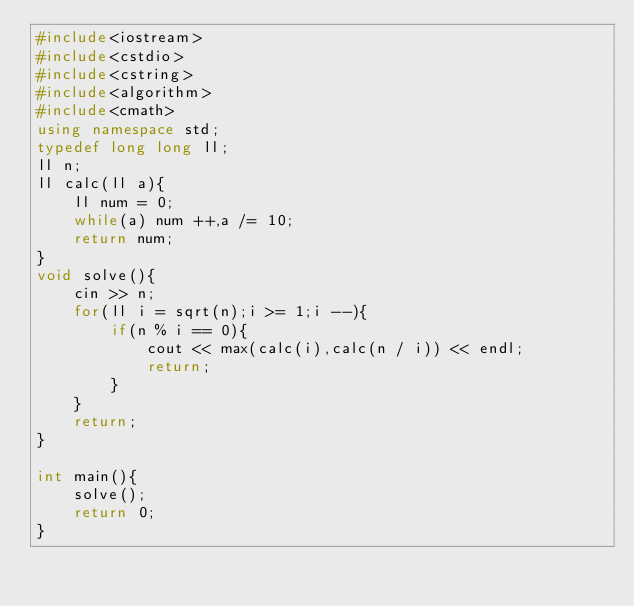<code> <loc_0><loc_0><loc_500><loc_500><_C++_>#include<iostream>
#include<cstdio>
#include<cstring>
#include<algorithm>
#include<cmath> 
using namespace std;
typedef long long ll;
ll n;
ll calc(ll a){
	ll num = 0;
	while(a) num ++,a /= 10;
	return num;
}
void solve(){
	cin >> n;
	for(ll i = sqrt(n);i >= 1;i --){
		if(n % i == 0){
			cout << max(calc(i),calc(n / i)) << endl;
			return;
		}
	}
	return;
}

int main(){
	solve();
	return 0;
}</code> 